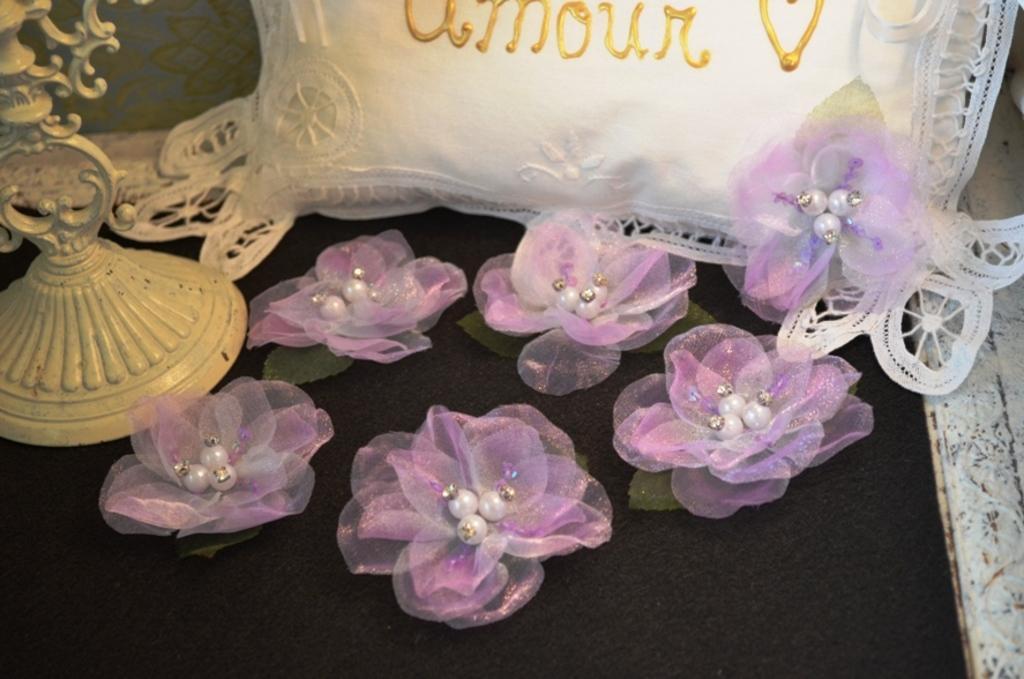Please provide a concise description of this image. In this image I can see few purple and white color artificial flowers. Back I can see the white color pillow and the cream color object. They are on the black surface. 